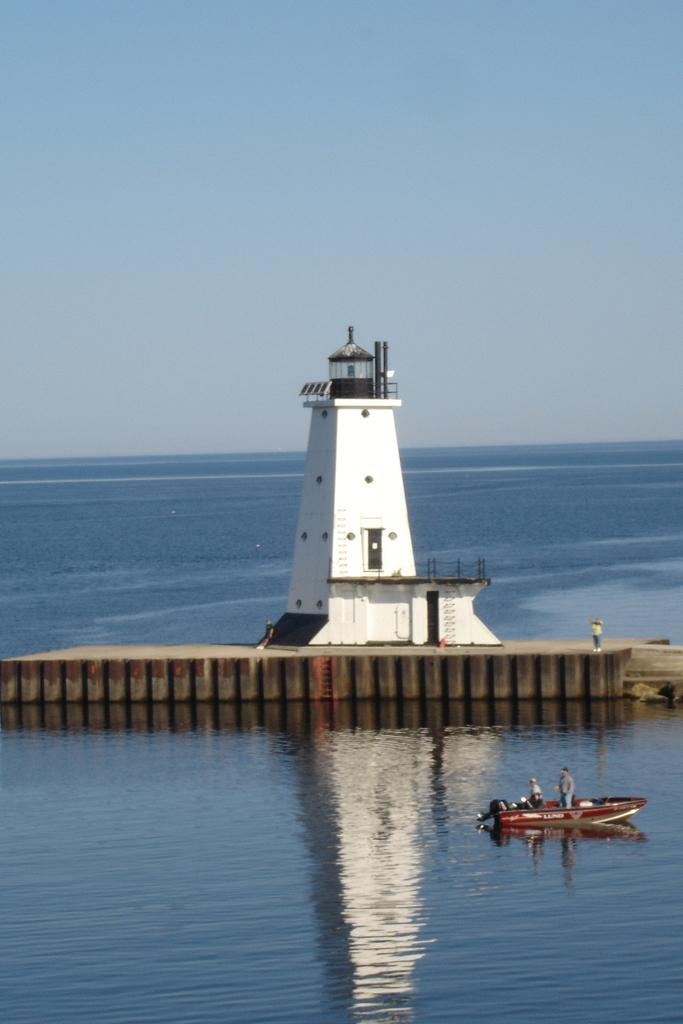What is the main subject of the image? The main subject of the image is a boat on the water. How many people are on the boat? There are two people on the boat. What else can be seen in the image besides the boat and people? There is a platform with a person on it, and a building on the platform. What is visible in the background of the image? The sky is visible in the background of the image. What type of coal is being used to fuel the boat in the image? There is no coal present in the image, and the boat's fuel source is not mentioned. What flavor of jam is being served on the platform in the image? There is no jam present in the image, and no food or beverages are mentioned. 